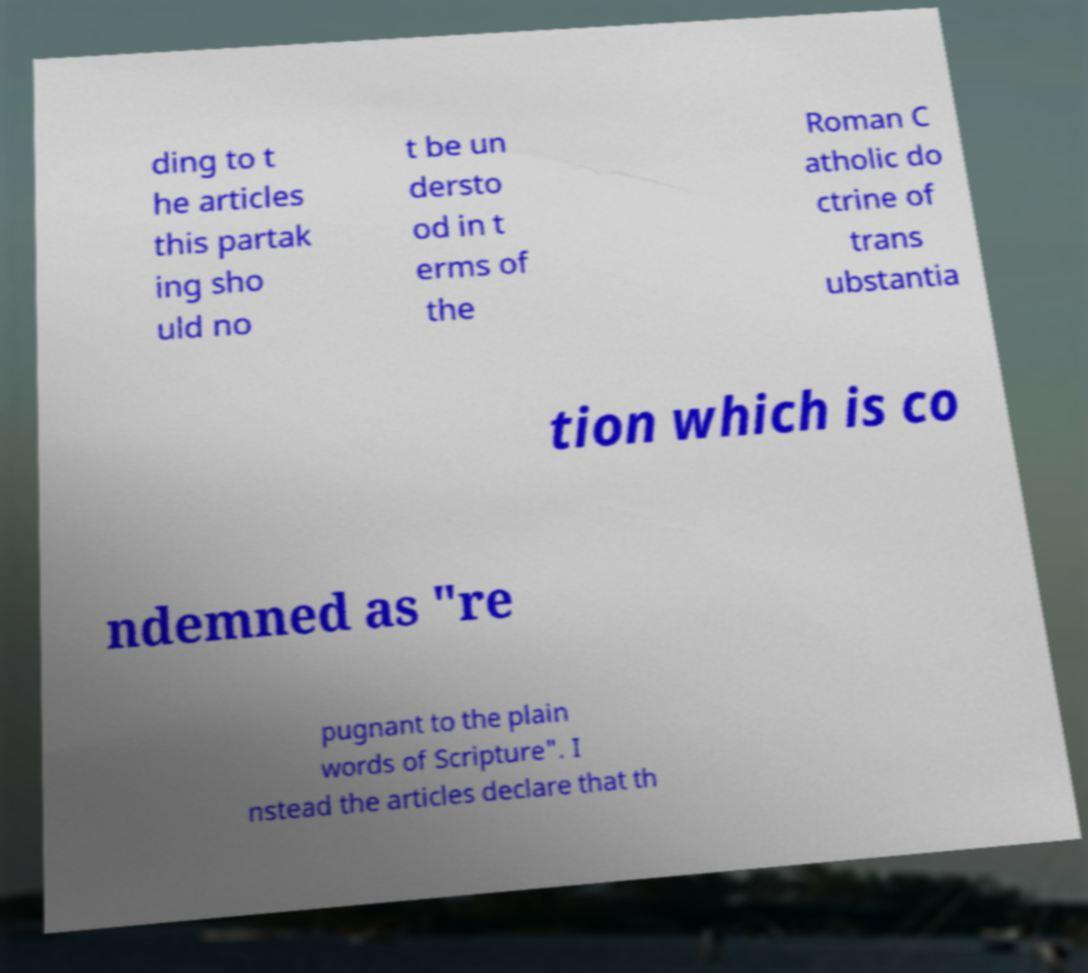I need the written content from this picture converted into text. Can you do that? ding to t he articles this partak ing sho uld no t be un dersto od in t erms of the Roman C atholic do ctrine of trans ubstantia tion which is co ndemned as "re pugnant to the plain words of Scripture". I nstead the articles declare that th 